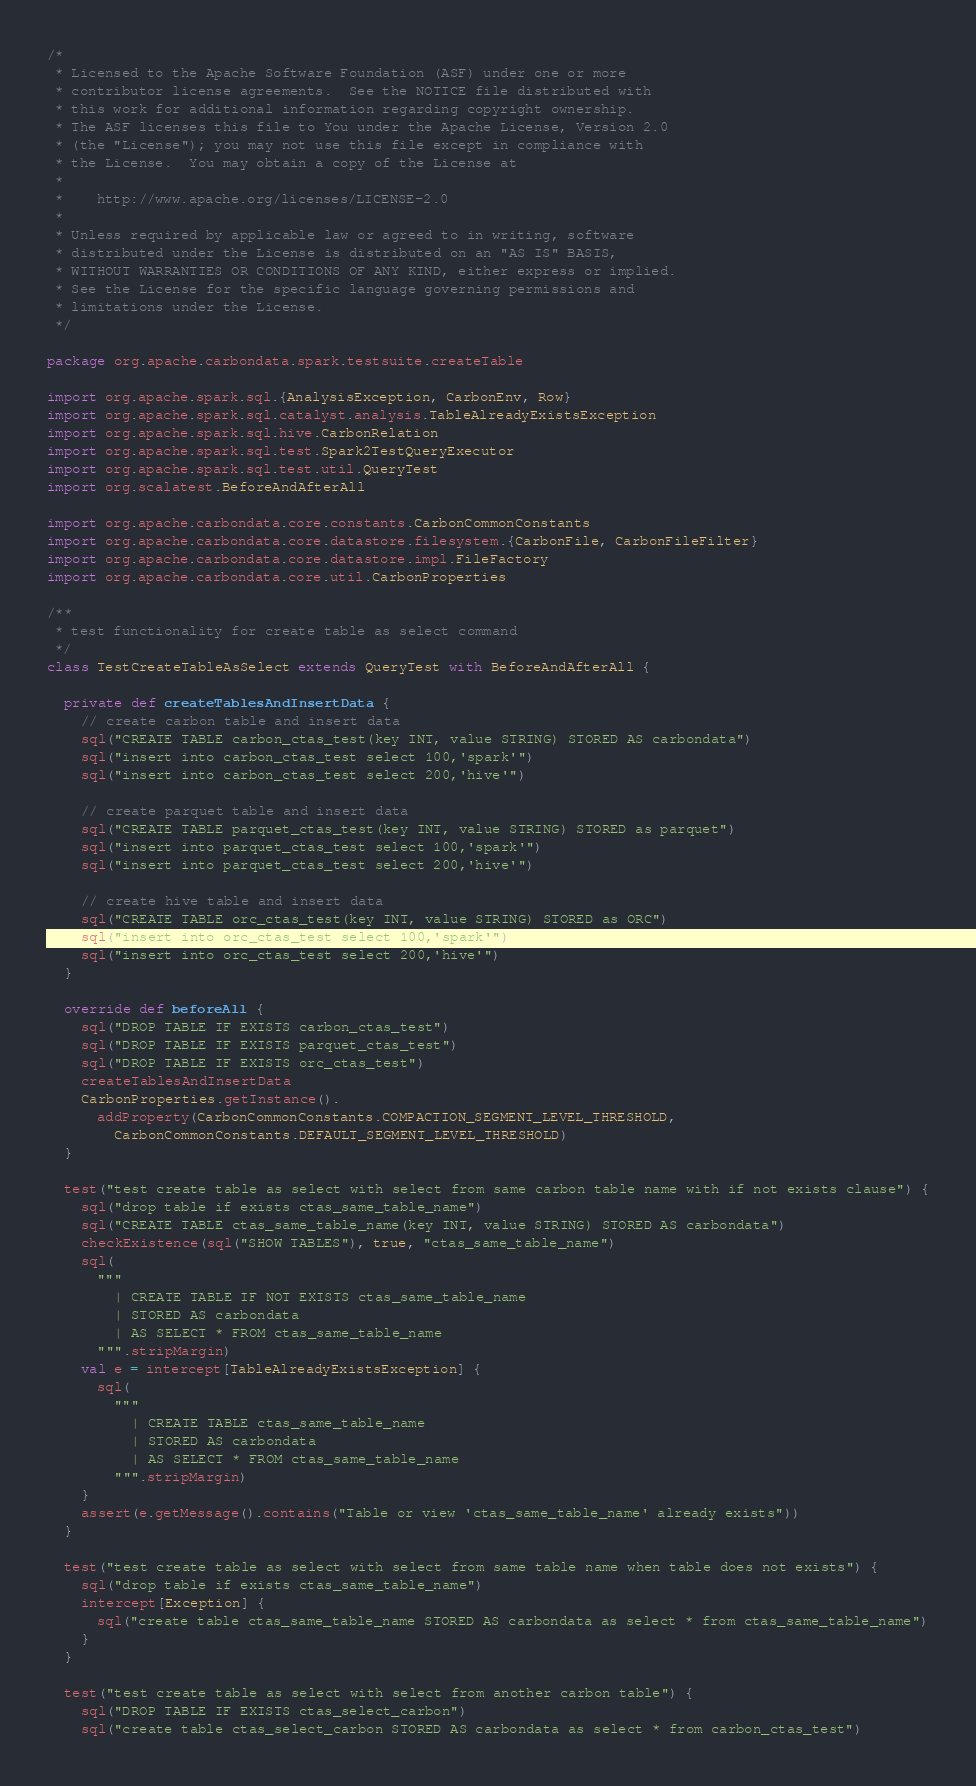<code> <loc_0><loc_0><loc_500><loc_500><_Scala_>/*
 * Licensed to the Apache Software Foundation (ASF) under one or more
 * contributor license agreements.  See the NOTICE file distributed with
 * this work for additional information regarding copyright ownership.
 * The ASF licenses this file to You under the Apache License, Version 2.0
 * (the "License"); you may not use this file except in compliance with
 * the License.  You may obtain a copy of the License at
 *
 *    http://www.apache.org/licenses/LICENSE-2.0
 *
 * Unless required by applicable law or agreed to in writing, software
 * distributed under the License is distributed on an "AS IS" BASIS,
 * WITHOUT WARRANTIES OR CONDITIONS OF ANY KIND, either express or implied.
 * See the License for the specific language governing permissions and
 * limitations under the License.
 */

package org.apache.carbondata.spark.testsuite.createTable

import org.apache.spark.sql.{AnalysisException, CarbonEnv, Row}
import org.apache.spark.sql.catalyst.analysis.TableAlreadyExistsException
import org.apache.spark.sql.hive.CarbonRelation
import org.apache.spark.sql.test.Spark2TestQueryExecutor
import org.apache.spark.sql.test.util.QueryTest
import org.scalatest.BeforeAndAfterAll

import org.apache.carbondata.core.constants.CarbonCommonConstants
import org.apache.carbondata.core.datastore.filesystem.{CarbonFile, CarbonFileFilter}
import org.apache.carbondata.core.datastore.impl.FileFactory
import org.apache.carbondata.core.util.CarbonProperties

/**
 * test functionality for create table as select command
 */
class TestCreateTableAsSelect extends QueryTest with BeforeAndAfterAll {

  private def createTablesAndInsertData {
    // create carbon table and insert data
    sql("CREATE TABLE carbon_ctas_test(key INT, value STRING) STORED AS carbondata")
    sql("insert into carbon_ctas_test select 100,'spark'")
    sql("insert into carbon_ctas_test select 200,'hive'")

    // create parquet table and insert data
    sql("CREATE TABLE parquet_ctas_test(key INT, value STRING) STORED as parquet")
    sql("insert into parquet_ctas_test select 100,'spark'")
    sql("insert into parquet_ctas_test select 200,'hive'")

    // create hive table and insert data
    sql("CREATE TABLE orc_ctas_test(key INT, value STRING) STORED as ORC")
    sql("insert into orc_ctas_test select 100,'spark'")
    sql("insert into orc_ctas_test select 200,'hive'")
  }

  override def beforeAll {
    sql("DROP TABLE IF EXISTS carbon_ctas_test")
    sql("DROP TABLE IF EXISTS parquet_ctas_test")
    sql("DROP TABLE IF EXISTS orc_ctas_test")
    createTablesAndInsertData
    CarbonProperties.getInstance().
      addProperty(CarbonCommonConstants.COMPACTION_SEGMENT_LEVEL_THRESHOLD,
        CarbonCommonConstants.DEFAULT_SEGMENT_LEVEL_THRESHOLD)
  }

  test("test create table as select with select from same carbon table name with if not exists clause") {
    sql("drop table if exists ctas_same_table_name")
    sql("CREATE TABLE ctas_same_table_name(key INT, value STRING) STORED AS carbondata")
    checkExistence(sql("SHOW TABLES"), true, "ctas_same_table_name")
    sql(
      """
        | CREATE TABLE IF NOT EXISTS ctas_same_table_name
        | STORED AS carbondata
        | AS SELECT * FROM ctas_same_table_name
      """.stripMargin)
    val e = intercept[TableAlreadyExistsException] {
      sql(
        """
          | CREATE TABLE ctas_same_table_name
          | STORED AS carbondata
          | AS SELECT * FROM ctas_same_table_name
        """.stripMargin)
    }
    assert(e.getMessage().contains("Table or view 'ctas_same_table_name' already exists"))
  }

  test("test create table as select with select from same table name when table does not exists") {
    sql("drop table if exists ctas_same_table_name")
    intercept[Exception] {
      sql("create table ctas_same_table_name STORED AS carbondata as select * from ctas_same_table_name")
    }
  }

  test("test create table as select with select from another carbon table") {
    sql("DROP TABLE IF EXISTS ctas_select_carbon")
    sql("create table ctas_select_carbon STORED AS carbondata as select * from carbon_ctas_test")</code> 